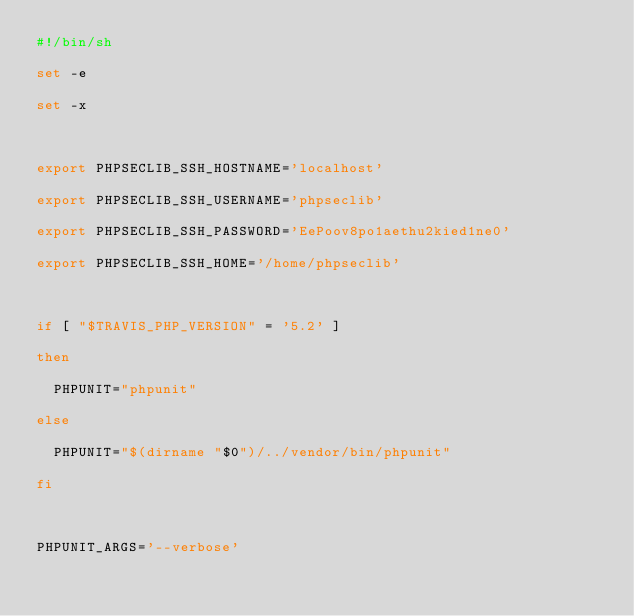<code> <loc_0><loc_0><loc_500><loc_500><_Bash_>#!/bin/sh
set -e
set -x

export PHPSECLIB_SSH_HOSTNAME='localhost'
export PHPSECLIB_SSH_USERNAME='phpseclib'
export PHPSECLIB_SSH_PASSWORD='EePoov8po1aethu2kied1ne0'
export PHPSECLIB_SSH_HOME='/home/phpseclib'

if [ "$TRAVIS_PHP_VERSION" = '5.2' ]
then
  PHPUNIT="phpunit"
else
  PHPUNIT="$(dirname "$0")/../vendor/bin/phpunit"
fi

PHPUNIT_ARGS='--verbose'</code> 